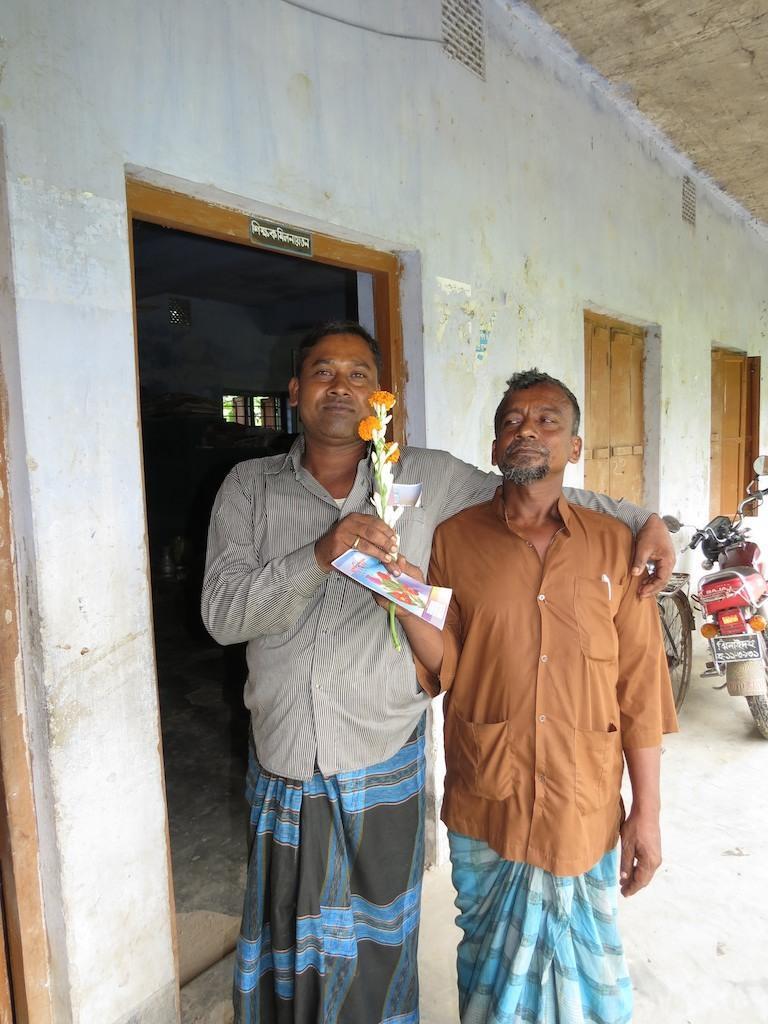Can you describe this image briefly? In this picture there are two men holding a card and it looks like a flower bouquet. Behind the people there is a bicycle, a bike and a wall with windows. 